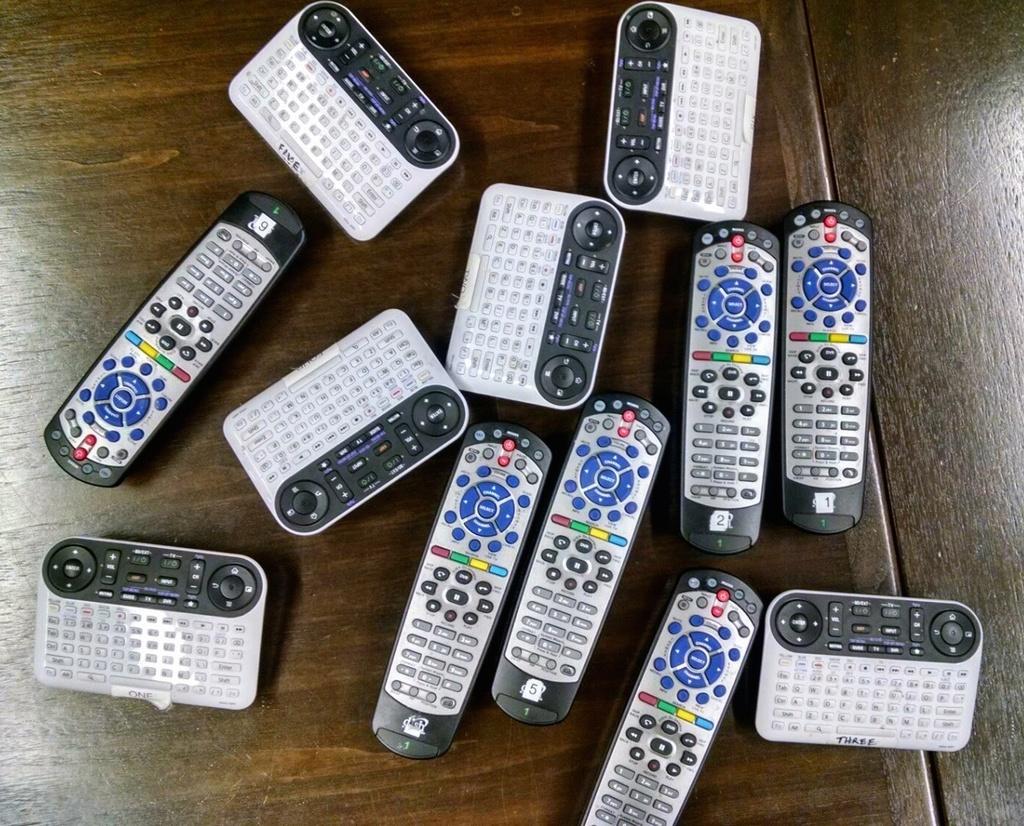What number is on the bottom of the remote on the right?
Keep it short and to the point. Three. 